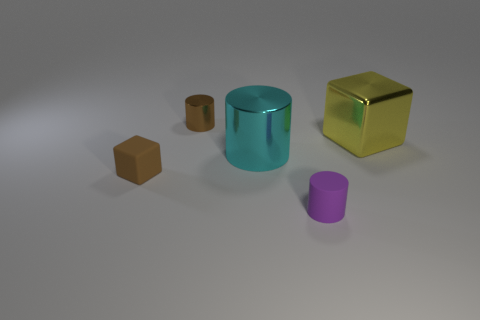Subtract all large cyan shiny cylinders. How many cylinders are left? 2 Subtract all purple cylinders. How many cylinders are left? 2 Subtract 1 cylinders. How many cylinders are left? 2 Add 1 large brown balls. How many objects exist? 6 Subtract all cylinders. How many objects are left? 2 Subtract all gray cylinders. Subtract all cyan cubes. How many cylinders are left? 3 Subtract all tiny brown matte blocks. Subtract all purple matte things. How many objects are left? 3 Add 4 yellow metallic cubes. How many yellow metallic cubes are left? 5 Add 4 tiny brown rubber things. How many tiny brown rubber things exist? 5 Subtract 0 gray spheres. How many objects are left? 5 